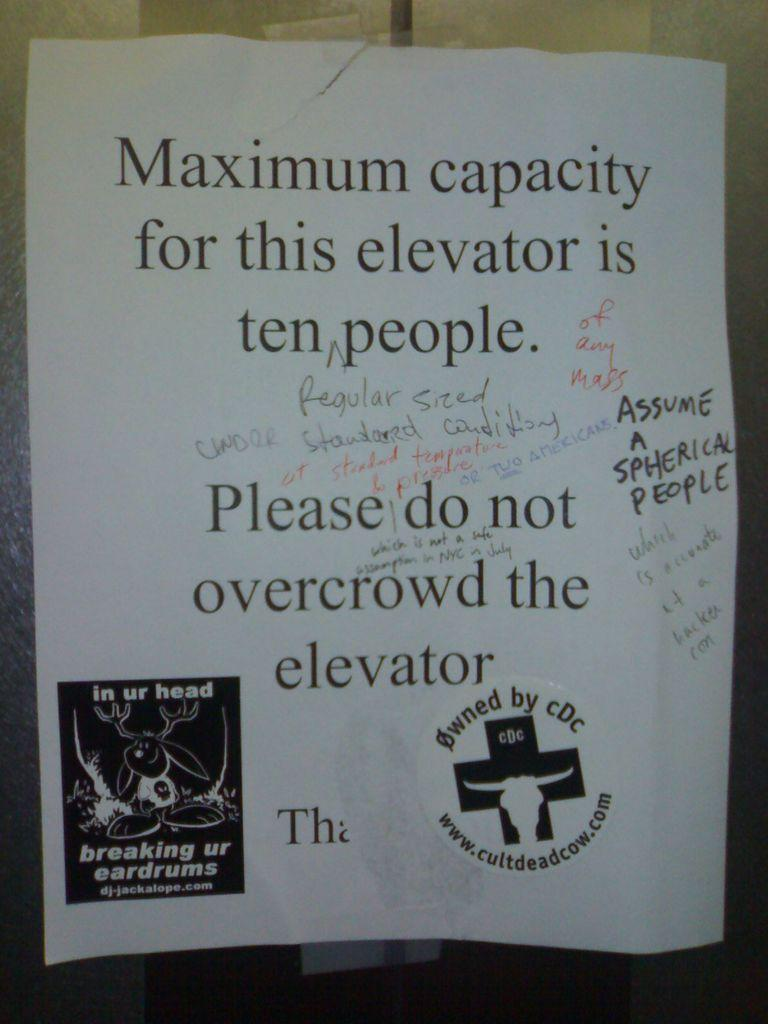<image>
Render a clear and concise summary of the photo. People have written comments on a sign which tells us that the maximum capacity for the elevator is ten people. 